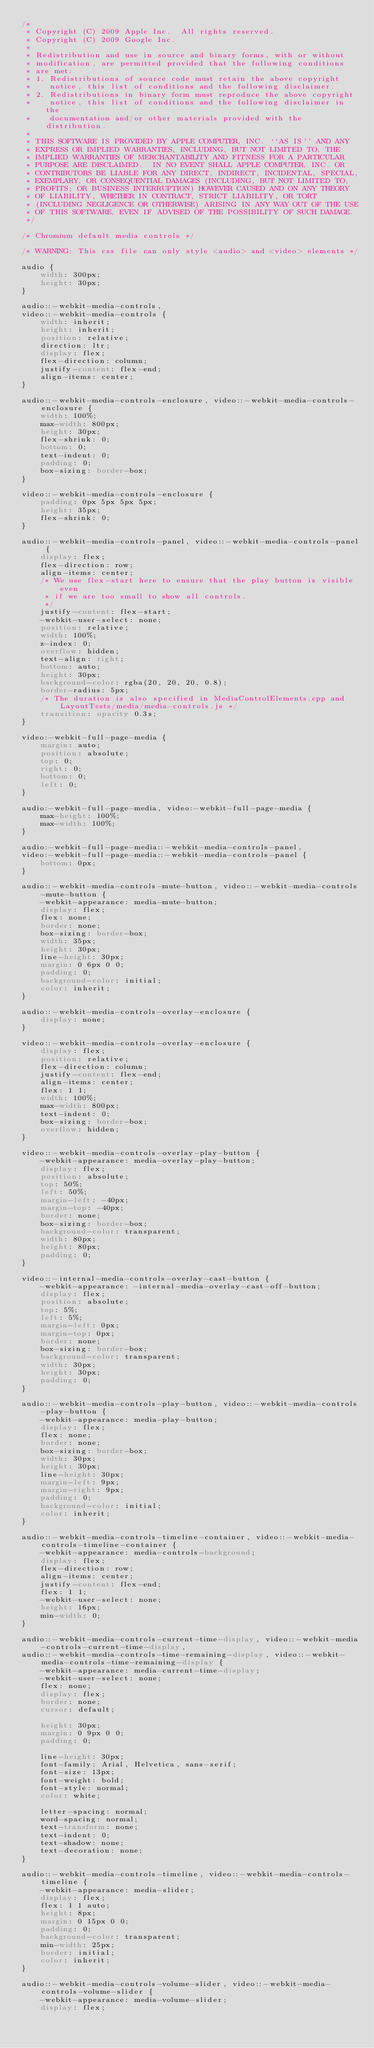<code> <loc_0><loc_0><loc_500><loc_500><_CSS_>/*
 * Copyright (C) 2009 Apple Inc.  All rights reserved.
 * Copyright (C) 2009 Google Inc.
 *
 * Redistribution and use in source and binary forms, with or without
 * modification, are permitted provided that the following conditions
 * are met:
 * 1. Redistributions of source code must retain the above copyright
 *    notice, this list of conditions and the following disclaimer.
 * 2. Redistributions in binary form must reproduce the above copyright
 *    notice, this list of conditions and the following disclaimer in the
 *    documentation and/or other materials provided with the distribution.
 *
 * THIS SOFTWARE IS PROVIDED BY APPLE COMPUTER, INC. ``AS IS'' AND ANY
 * EXPRESS OR IMPLIED WARRANTIES, INCLUDING, BUT NOT LIMITED TO, THE
 * IMPLIED WARRANTIES OF MERCHANTABILITY AND FITNESS FOR A PARTICULAR
 * PURPOSE ARE DISCLAIMED.  IN NO EVENT SHALL APPLE COMPUTER, INC. OR
 * CONTRIBUTORS BE LIABLE FOR ANY DIRECT, INDIRECT, INCIDENTAL, SPECIAL,
 * EXEMPLARY, OR CONSEQUENTIAL DAMAGES (INCLUDING, BUT NOT LIMITED TO,
 * PROFITS; OR BUSINESS INTERRUPTION) HOWEVER CAUSED AND ON ANY THEORY
 * OF LIABILITY, WHETHER IN CONTRACT, STRICT LIABILITY, OR TORT
 * (INCLUDING NEGLIGENCE OR OTHERWISE) ARISING IN ANY WAY OUT OF THE USE
 * OF THIS SOFTWARE, EVEN IF ADVISED OF THE POSSIBILITY OF SUCH DAMAGE.
 */

/* Chromium default media controls */

/* WARNING: This css file can only style <audio> and <video> elements */

audio {
    width: 300px;
    height: 30px;
}

audio::-webkit-media-controls,
video::-webkit-media-controls {
    width: inherit;
    height: inherit;
    position: relative;
    direction: ltr;
    display: flex;
    flex-direction: column;
    justify-content: flex-end;
    align-items: center;
}

audio::-webkit-media-controls-enclosure, video::-webkit-media-controls-enclosure {
    width: 100%;
    max-width: 800px;
    height: 30px;
    flex-shrink: 0;
    bottom: 0;
    text-indent: 0;
    padding: 0;
    box-sizing: border-box;
}

video::-webkit-media-controls-enclosure {
    padding: 0px 5px 5px 5px;
    height: 35px;
    flex-shrink: 0;
}

audio::-webkit-media-controls-panel, video::-webkit-media-controls-panel {
    display: flex;
    flex-direction: row;
    align-items: center;
    /* We use flex-start here to ensure that the play button is visible even
     * if we are too small to show all controls.
     */
    justify-content: flex-start;
    -webkit-user-select: none;
    position: relative;
    width: 100%;
    z-index: 0;
    overflow: hidden;
    text-align: right;
    bottom: auto;
    height: 30px;
    background-color: rgba(20, 20, 20, 0.8);
    border-radius: 5px;
    /* The duration is also specified in MediaControlElements.cpp and LayoutTests/media/media-controls.js */
    transition: opacity 0.3s;
}

video:-webkit-full-page-media {
    margin: auto;
    position: absolute;
    top: 0;
    right: 0;
    bottom: 0;
    left: 0;
}

audio:-webkit-full-page-media, video:-webkit-full-page-media {
    max-height: 100%;
    max-width: 100%;
}

audio:-webkit-full-page-media::-webkit-media-controls-panel,
video:-webkit-full-page-media::-webkit-media-controls-panel {
    bottom: 0px;
}

audio::-webkit-media-controls-mute-button, video::-webkit-media-controls-mute-button {
    -webkit-appearance: media-mute-button;
    display: flex;
    flex: none;
    border: none;
    box-sizing: border-box;
    width: 35px;
    height: 30px;
    line-height: 30px;
    margin: 0 6px 0 0;
    padding: 0;
    background-color: initial;
    color: inherit;
}

audio::-webkit-media-controls-overlay-enclosure {
    display: none;
}

video::-webkit-media-controls-overlay-enclosure {
    display: flex;
    position: relative;
    flex-direction: column;
    justify-content: flex-end;
    align-items: center;
    flex: 1 1;
    width: 100%;
    max-width: 800px;
    text-indent: 0;
    box-sizing: border-box;
    overflow: hidden;
}

video::-webkit-media-controls-overlay-play-button {
    -webkit-appearance: media-overlay-play-button;
    display: flex;
    position: absolute;
    top: 50%;
    left: 50%;
    margin-left: -40px;
    margin-top: -40px;
    border: none;
    box-sizing: border-box;
    background-color: transparent;
    width: 80px;
    height: 80px;
    padding: 0;
}

video::-internal-media-controls-overlay-cast-button {
    -webkit-appearance: -internal-media-overlay-cast-off-button;
    display: flex;
    position: absolute;
    top: 5%;
    left: 5%;
    margin-left: 0px;
    margin-top: 0px;
    border: none;
    box-sizing: border-box;
    background-color: transparent;
    width: 30px;
    height: 30px;
    padding: 0;
}

audio::-webkit-media-controls-play-button, video::-webkit-media-controls-play-button {
    -webkit-appearance: media-play-button;
    display: flex;
    flex: none;
    border: none;
    box-sizing: border-box;
    width: 30px;
    height: 30px;
    line-height: 30px;
    margin-left: 9px;
    margin-right: 9px;
    padding: 0;
    background-color: initial;
    color: inherit;
}

audio::-webkit-media-controls-timeline-container, video::-webkit-media-controls-timeline-container {
    -webkit-appearance: media-controls-background;
    display: flex;
    flex-direction: row;
    align-items: center;
    justify-content: flex-end;
    flex: 1 1;
    -webkit-user-select: none;
    height: 16px;
    min-width: 0;
}

audio::-webkit-media-controls-current-time-display, video::-webkit-media-controls-current-time-display,
audio::-webkit-media-controls-time-remaining-display, video::-webkit-media-controls-time-remaining-display {
    -webkit-appearance: media-current-time-display;
    -webkit-user-select: none;
    flex: none;
    display: flex;
    border: none;
    cursor: default;

    height: 30px;
    margin: 0 9px 0 0;
    padding: 0;

    line-height: 30px;
    font-family: Arial, Helvetica, sans-serif;
    font-size: 13px;
    font-weight: bold;
    font-style: normal;
    color: white;

    letter-spacing: normal;
    word-spacing: normal;
    text-transform: none;
    text-indent: 0;
    text-shadow: none;
    text-decoration: none;
}

audio::-webkit-media-controls-timeline, video::-webkit-media-controls-timeline {
    -webkit-appearance: media-slider;
    display: flex;
    flex: 1 1 auto;
    height: 8px;
    margin: 0 15px 0 0;
    padding: 0;
    background-color: transparent;
    min-width: 25px;
    border: initial;
    color: inherit;
}

audio::-webkit-media-controls-volume-slider, video::-webkit-media-controls-volume-slider {
    -webkit-appearance: media-volume-slider;
    display: flex;</code> 